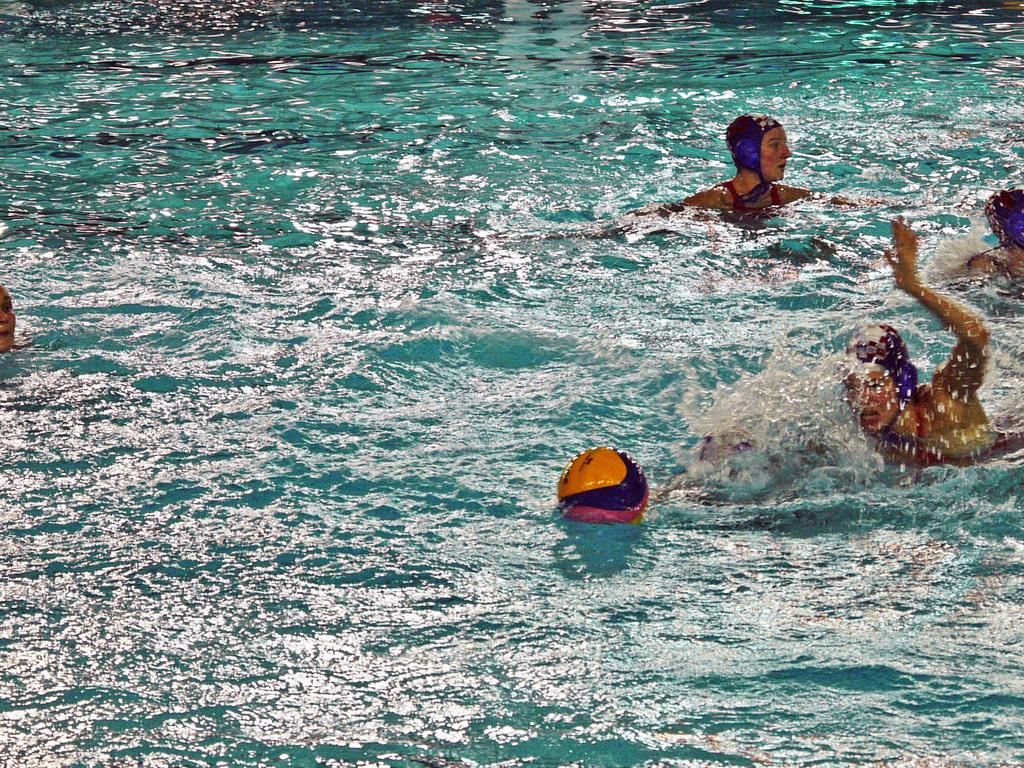What colors are present on the ball in the image? The ball in the image is orange and blue. Where is the ball located in the image? The ball is on the surface of the water. What can be seen in the water besides the ball? There are persons in the water. What is the color of the water in the image? The water is blue in color. What type of milk is being served to the fowl in the image? There is no milk or fowl present in the image; it features a ball on the surface of blue water with persons in the water. 